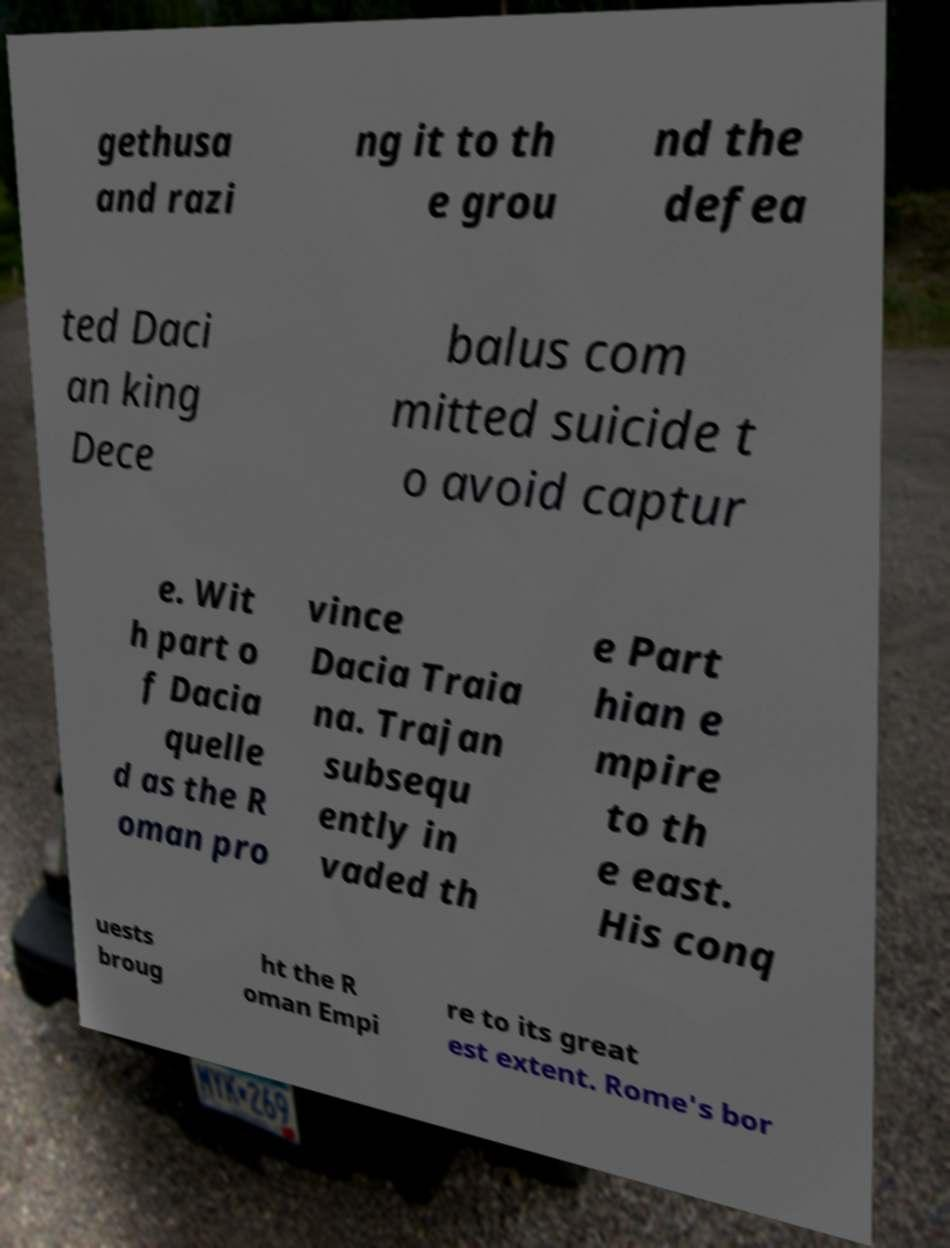For documentation purposes, I need the text within this image transcribed. Could you provide that? gethusa and razi ng it to th e grou nd the defea ted Daci an king Dece balus com mitted suicide t o avoid captur e. Wit h part o f Dacia quelle d as the R oman pro vince Dacia Traia na. Trajan subsequ ently in vaded th e Part hian e mpire to th e east. His conq uests broug ht the R oman Empi re to its great est extent. Rome's bor 